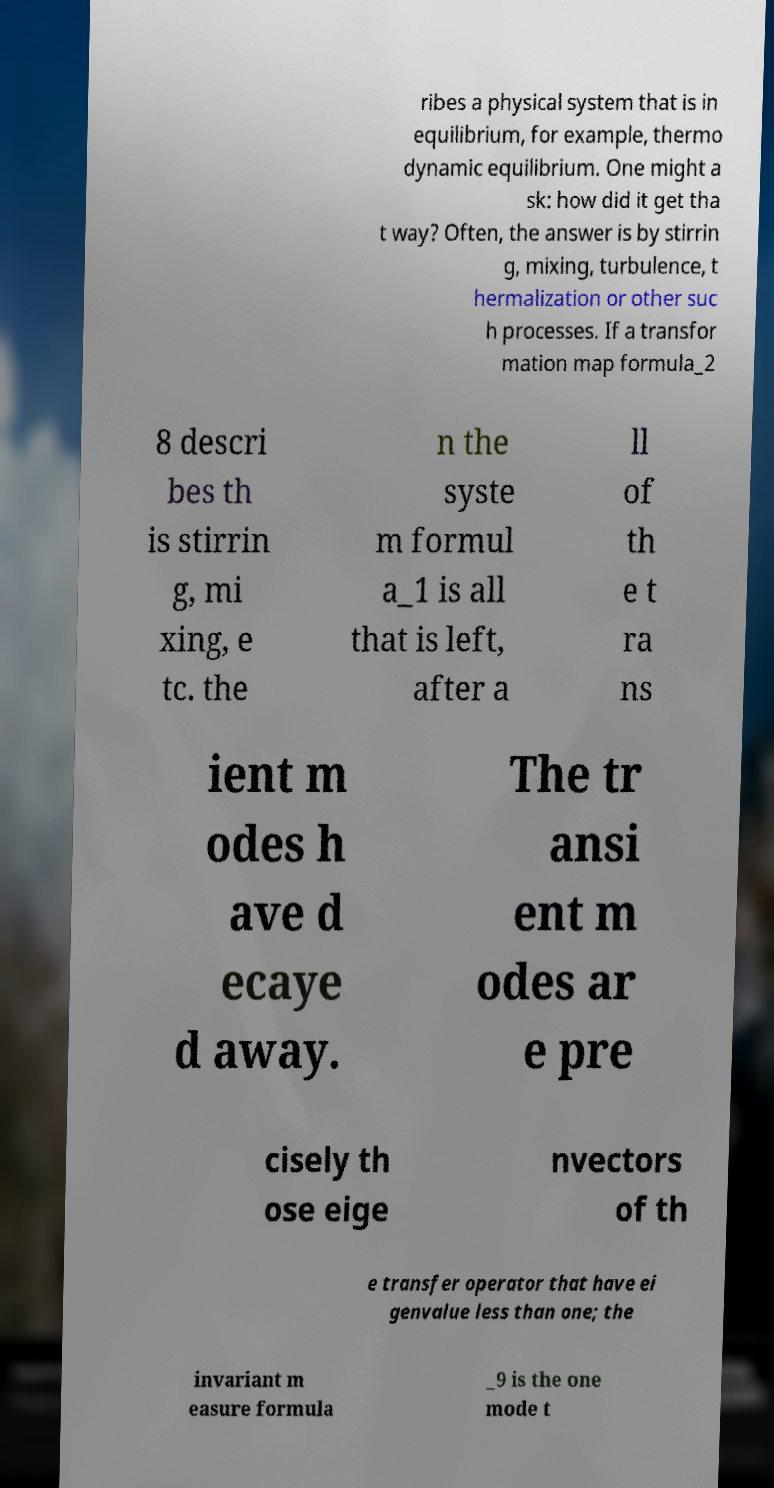Can you accurately transcribe the text from the provided image for me? ribes a physical system that is in equilibrium, for example, thermo dynamic equilibrium. One might a sk: how did it get tha t way? Often, the answer is by stirrin g, mixing, turbulence, t hermalization or other suc h processes. If a transfor mation map formula_2 8 descri bes th is stirrin g, mi xing, e tc. the n the syste m formul a_1 is all that is left, after a ll of th e t ra ns ient m odes h ave d ecaye d away. The tr ansi ent m odes ar e pre cisely th ose eige nvectors of th e transfer operator that have ei genvalue less than one; the invariant m easure formula _9 is the one mode t 